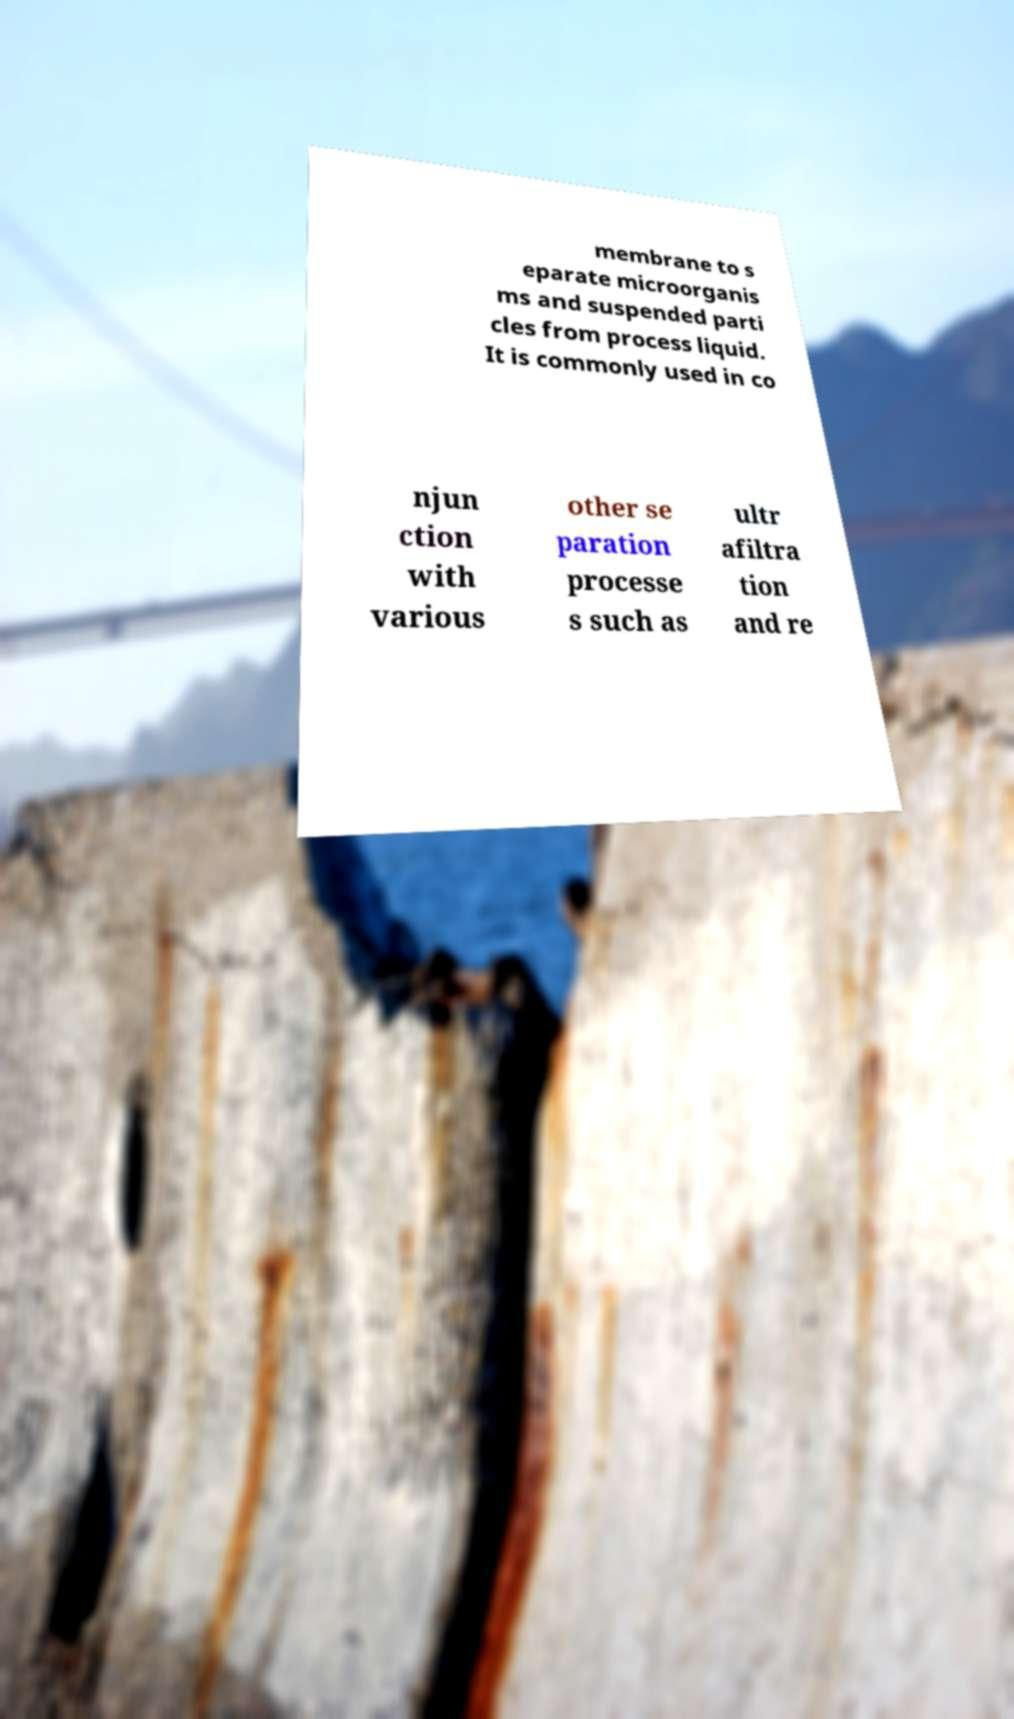Can you read and provide the text displayed in the image?This photo seems to have some interesting text. Can you extract and type it out for me? membrane to s eparate microorganis ms and suspended parti cles from process liquid. It is commonly used in co njun ction with various other se paration processe s such as ultr afiltra tion and re 